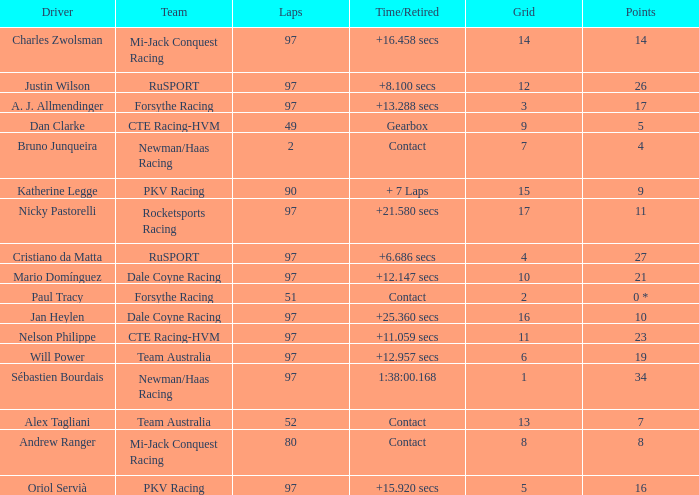What team does jan heylen race for? Dale Coyne Racing. Could you help me parse every detail presented in this table? {'header': ['Driver', 'Team', 'Laps', 'Time/Retired', 'Grid', 'Points'], 'rows': [['Charles Zwolsman', 'Mi-Jack Conquest Racing', '97', '+16.458 secs', '14', '14'], ['Justin Wilson', 'RuSPORT', '97', '+8.100 secs', '12', '26'], ['A. J. Allmendinger', 'Forsythe Racing', '97', '+13.288 secs', '3', '17'], ['Dan Clarke', 'CTE Racing-HVM', '49', 'Gearbox', '9', '5'], ['Bruno Junqueira', 'Newman/Haas Racing', '2', 'Contact', '7', '4'], ['Katherine Legge', 'PKV Racing', '90', '+ 7 Laps', '15', '9'], ['Nicky Pastorelli', 'Rocketsports Racing', '97', '+21.580 secs', '17', '11'], ['Cristiano da Matta', 'RuSPORT', '97', '+6.686 secs', '4', '27'], ['Mario Domínguez', 'Dale Coyne Racing', '97', '+12.147 secs', '10', '21'], ['Paul Tracy', 'Forsythe Racing', '51', 'Contact', '2', '0 *'], ['Jan Heylen', 'Dale Coyne Racing', '97', '+25.360 secs', '16', '10'], ['Nelson Philippe', 'CTE Racing-HVM', '97', '+11.059 secs', '11', '23'], ['Will Power', 'Team Australia', '97', '+12.957 secs', '6', '19'], ['Sébastien Bourdais', 'Newman/Haas Racing', '97', '1:38:00.168', '1', '34'], ['Alex Tagliani', 'Team Australia', '52', 'Contact', '13', '7'], ['Andrew Ranger', 'Mi-Jack Conquest Racing', '80', 'Contact', '8', '8'], ['Oriol Servià', 'PKV Racing', '97', '+15.920 secs', '5', '16']]} 